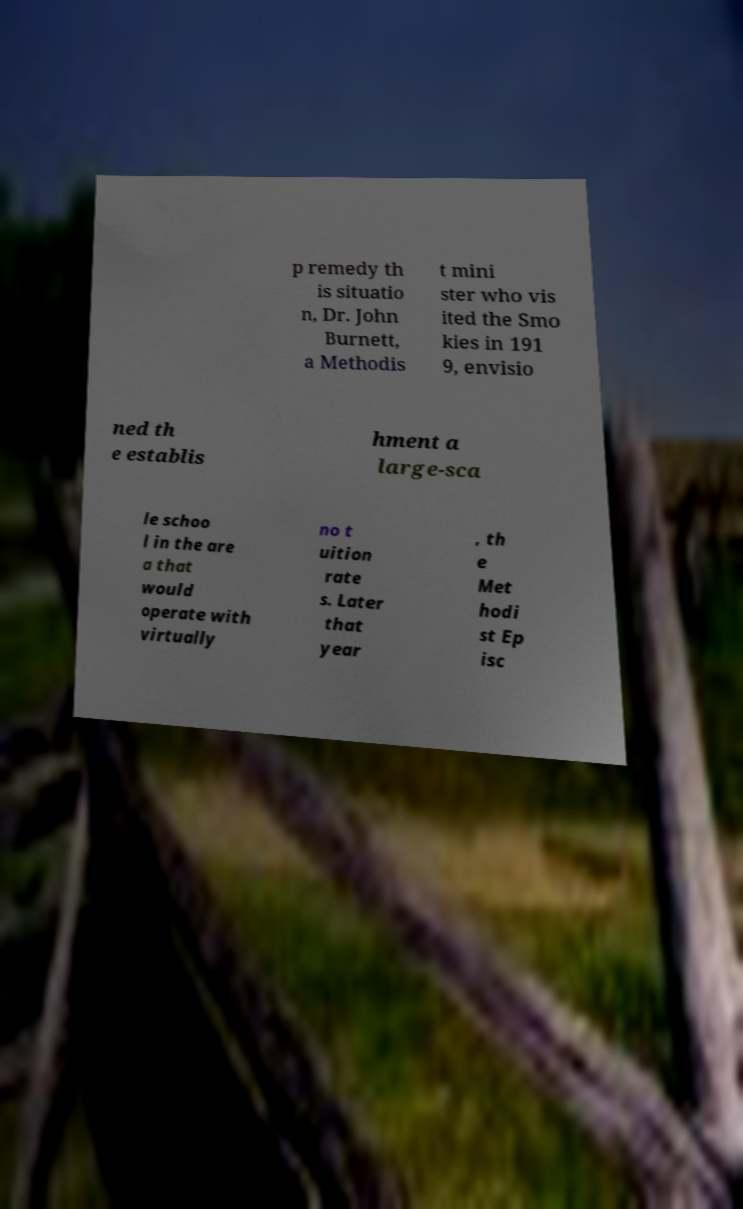I need the written content from this picture converted into text. Can you do that? p remedy th is situatio n, Dr. John Burnett, a Methodis t mini ster who vis ited the Smo kies in 191 9, envisio ned th e establis hment a large-sca le schoo l in the are a that would operate with virtually no t uition rate s. Later that year , th e Met hodi st Ep isc 